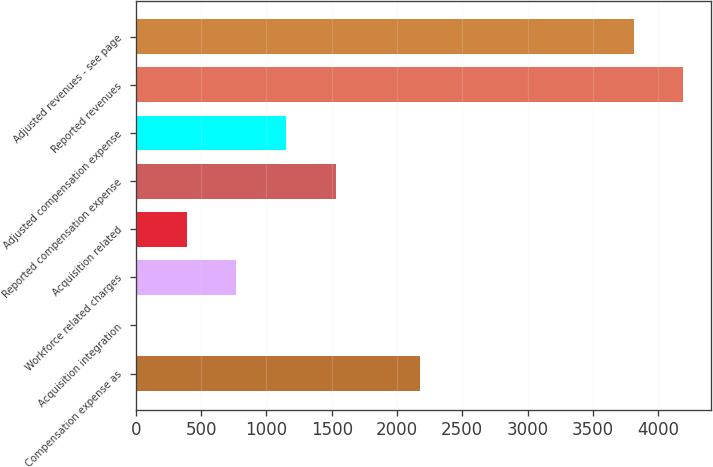<chart> <loc_0><loc_0><loc_500><loc_500><bar_chart><fcel>Compensation expense as<fcel>Acquisition integration<fcel>Workforce related charges<fcel>Acquisition related<fcel>Reported compensation expense<fcel>Adjusted compensation expense<fcel>Reported revenues<fcel>Adjusted revenues - see page<nl><fcel>2174.2<fcel>7.6<fcel>769.1<fcel>388.35<fcel>1530.6<fcel>1149.85<fcel>4192.45<fcel>3811.7<nl></chart> 